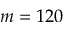Convert formula to latex. <formula><loc_0><loc_0><loc_500><loc_500>m = 1 2 0</formula> 